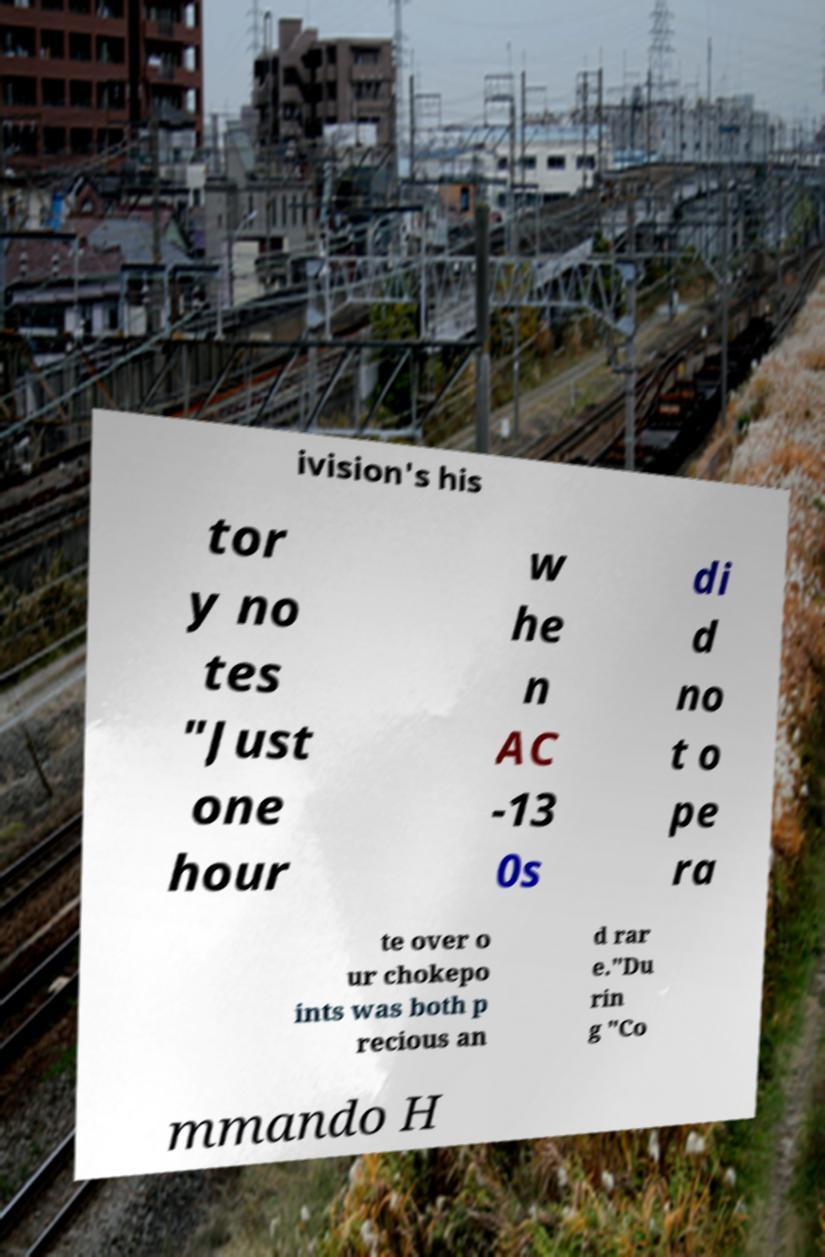Could you extract and type out the text from this image? ivision's his tor y no tes "Just one hour w he n AC -13 0s di d no t o pe ra te over o ur chokepo ints was both p recious an d rar e."Du rin g "Co mmando H 